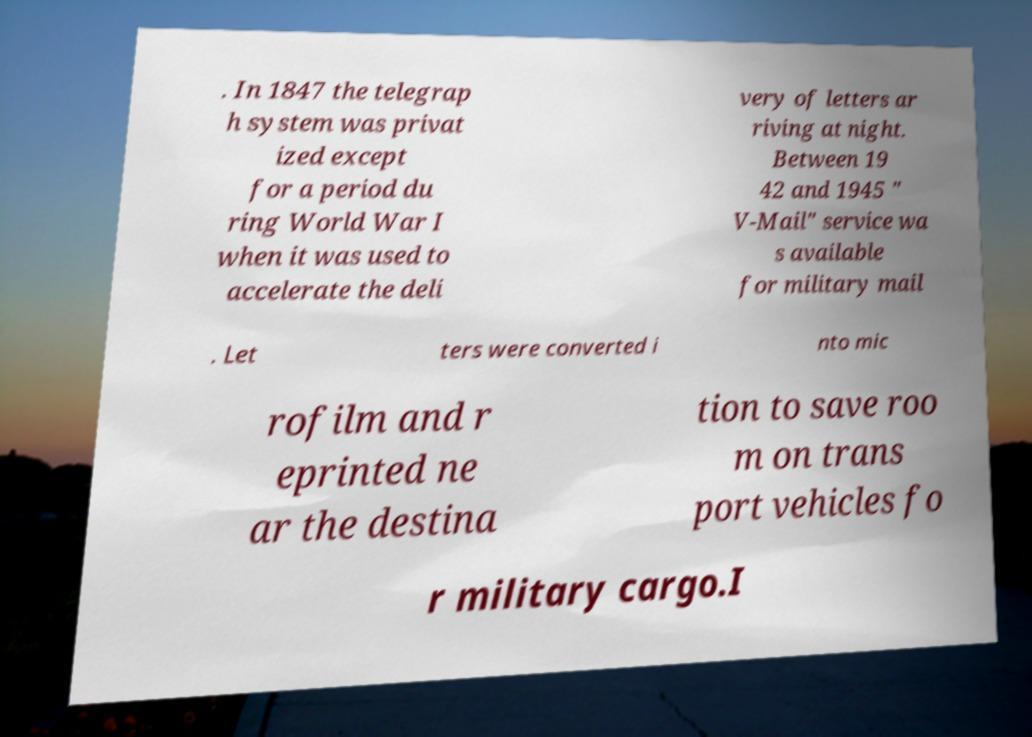Can you accurately transcribe the text from the provided image for me? . In 1847 the telegrap h system was privat ized except for a period du ring World War I when it was used to accelerate the deli very of letters ar riving at night. Between 19 42 and 1945 " V-Mail" service wa s available for military mail . Let ters were converted i nto mic rofilm and r eprinted ne ar the destina tion to save roo m on trans port vehicles fo r military cargo.I 